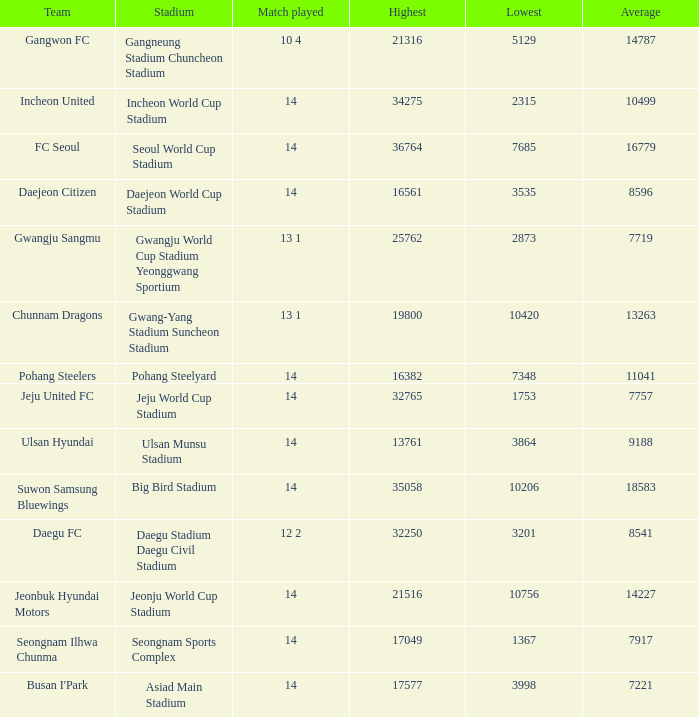What is the highest when pohang steelers is the team? 16382.0. Parse the table in full. {'header': ['Team', 'Stadium', 'Match played', 'Highest', 'Lowest', 'Average'], 'rows': [['Gangwon FC', 'Gangneung Stadium Chuncheon Stadium', '10 4', '21316', '5129', '14787'], ['Incheon United', 'Incheon World Cup Stadium', '14', '34275', '2315', '10499'], ['FC Seoul', 'Seoul World Cup Stadium', '14', '36764', '7685', '16779'], ['Daejeon Citizen', 'Daejeon World Cup Stadium', '14', '16561', '3535', '8596'], ['Gwangju Sangmu', 'Gwangju World Cup Stadium Yeonggwang Sportium', '13 1', '25762', '2873', '7719'], ['Chunnam Dragons', 'Gwang-Yang Stadium Suncheon Stadium', '13 1', '19800', '10420', '13263'], ['Pohang Steelers', 'Pohang Steelyard', '14', '16382', '7348', '11041'], ['Jeju United FC', 'Jeju World Cup Stadium', '14', '32765', '1753', '7757'], ['Ulsan Hyundai', 'Ulsan Munsu Stadium', '14', '13761', '3864', '9188'], ['Suwon Samsung Bluewings', 'Big Bird Stadium', '14', '35058', '10206', '18583'], ['Daegu FC', 'Daegu Stadium Daegu Civil Stadium', '12 2', '32250', '3201', '8541'], ['Jeonbuk Hyundai Motors', 'Jeonju World Cup Stadium', '14', '21516', '10756', '14227'], ['Seongnam Ilhwa Chunma', 'Seongnam Sports Complex', '14', '17049', '1367', '7917'], ["Busan I'Park", 'Asiad Main Stadium', '14', '17577', '3998', '7221']]} 